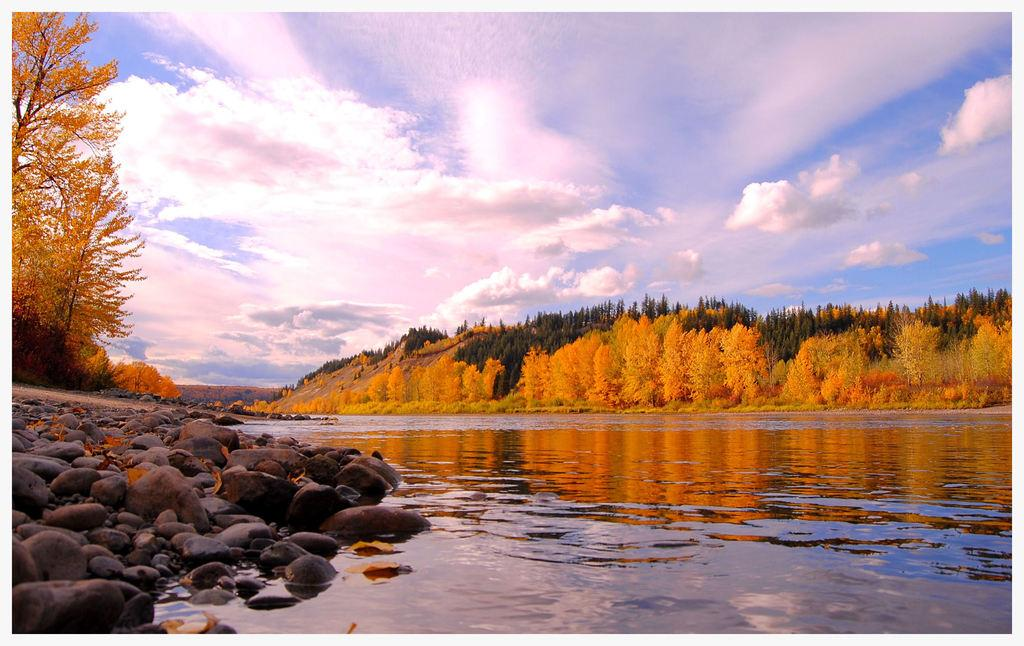What type of natural elements can be seen in the image? There are many trees, plants, stones, and water visible in the image. What is the condition of the sky in the background of the image? The sky is cloudy in the background of the image. Can you hear the quiet sound of a bag rustling in the image? There is no bag or sound present in the image, as it only features natural elements such as trees, plants, stones, water, and a cloudy sky. 